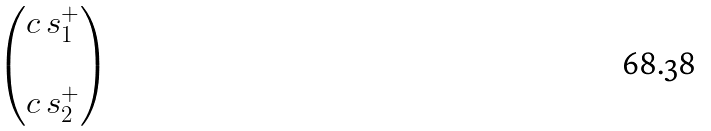<formula> <loc_0><loc_0><loc_500><loc_500>\begin{pmatrix} c \, s ^ { + } _ { 1 } \\ \\ c \, s ^ { + } _ { 2 } \end{pmatrix}</formula> 